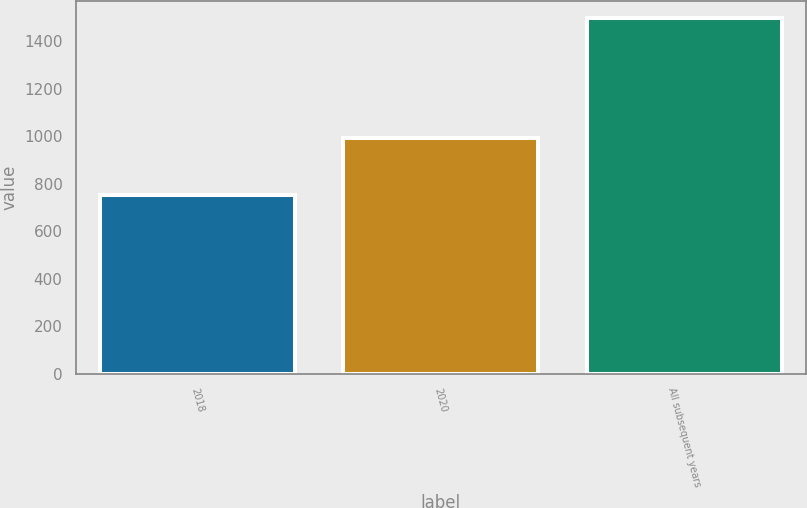<chart> <loc_0><loc_0><loc_500><loc_500><bar_chart><fcel>2018<fcel>2020<fcel>All subsequent years<nl><fcel>752<fcel>994<fcel>1496<nl></chart> 